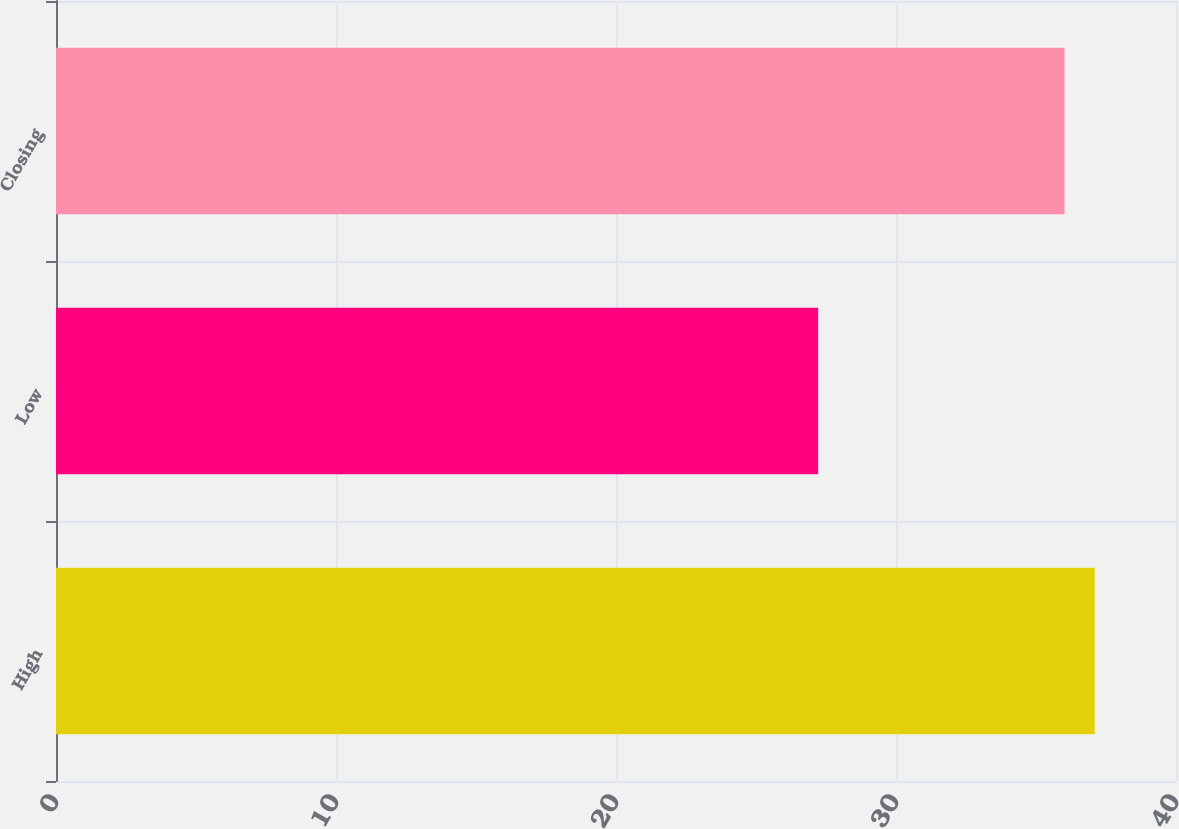<chart> <loc_0><loc_0><loc_500><loc_500><bar_chart><fcel>High<fcel>Low<fcel>Closing<nl><fcel>37.1<fcel>27.22<fcel>36.02<nl></chart> 